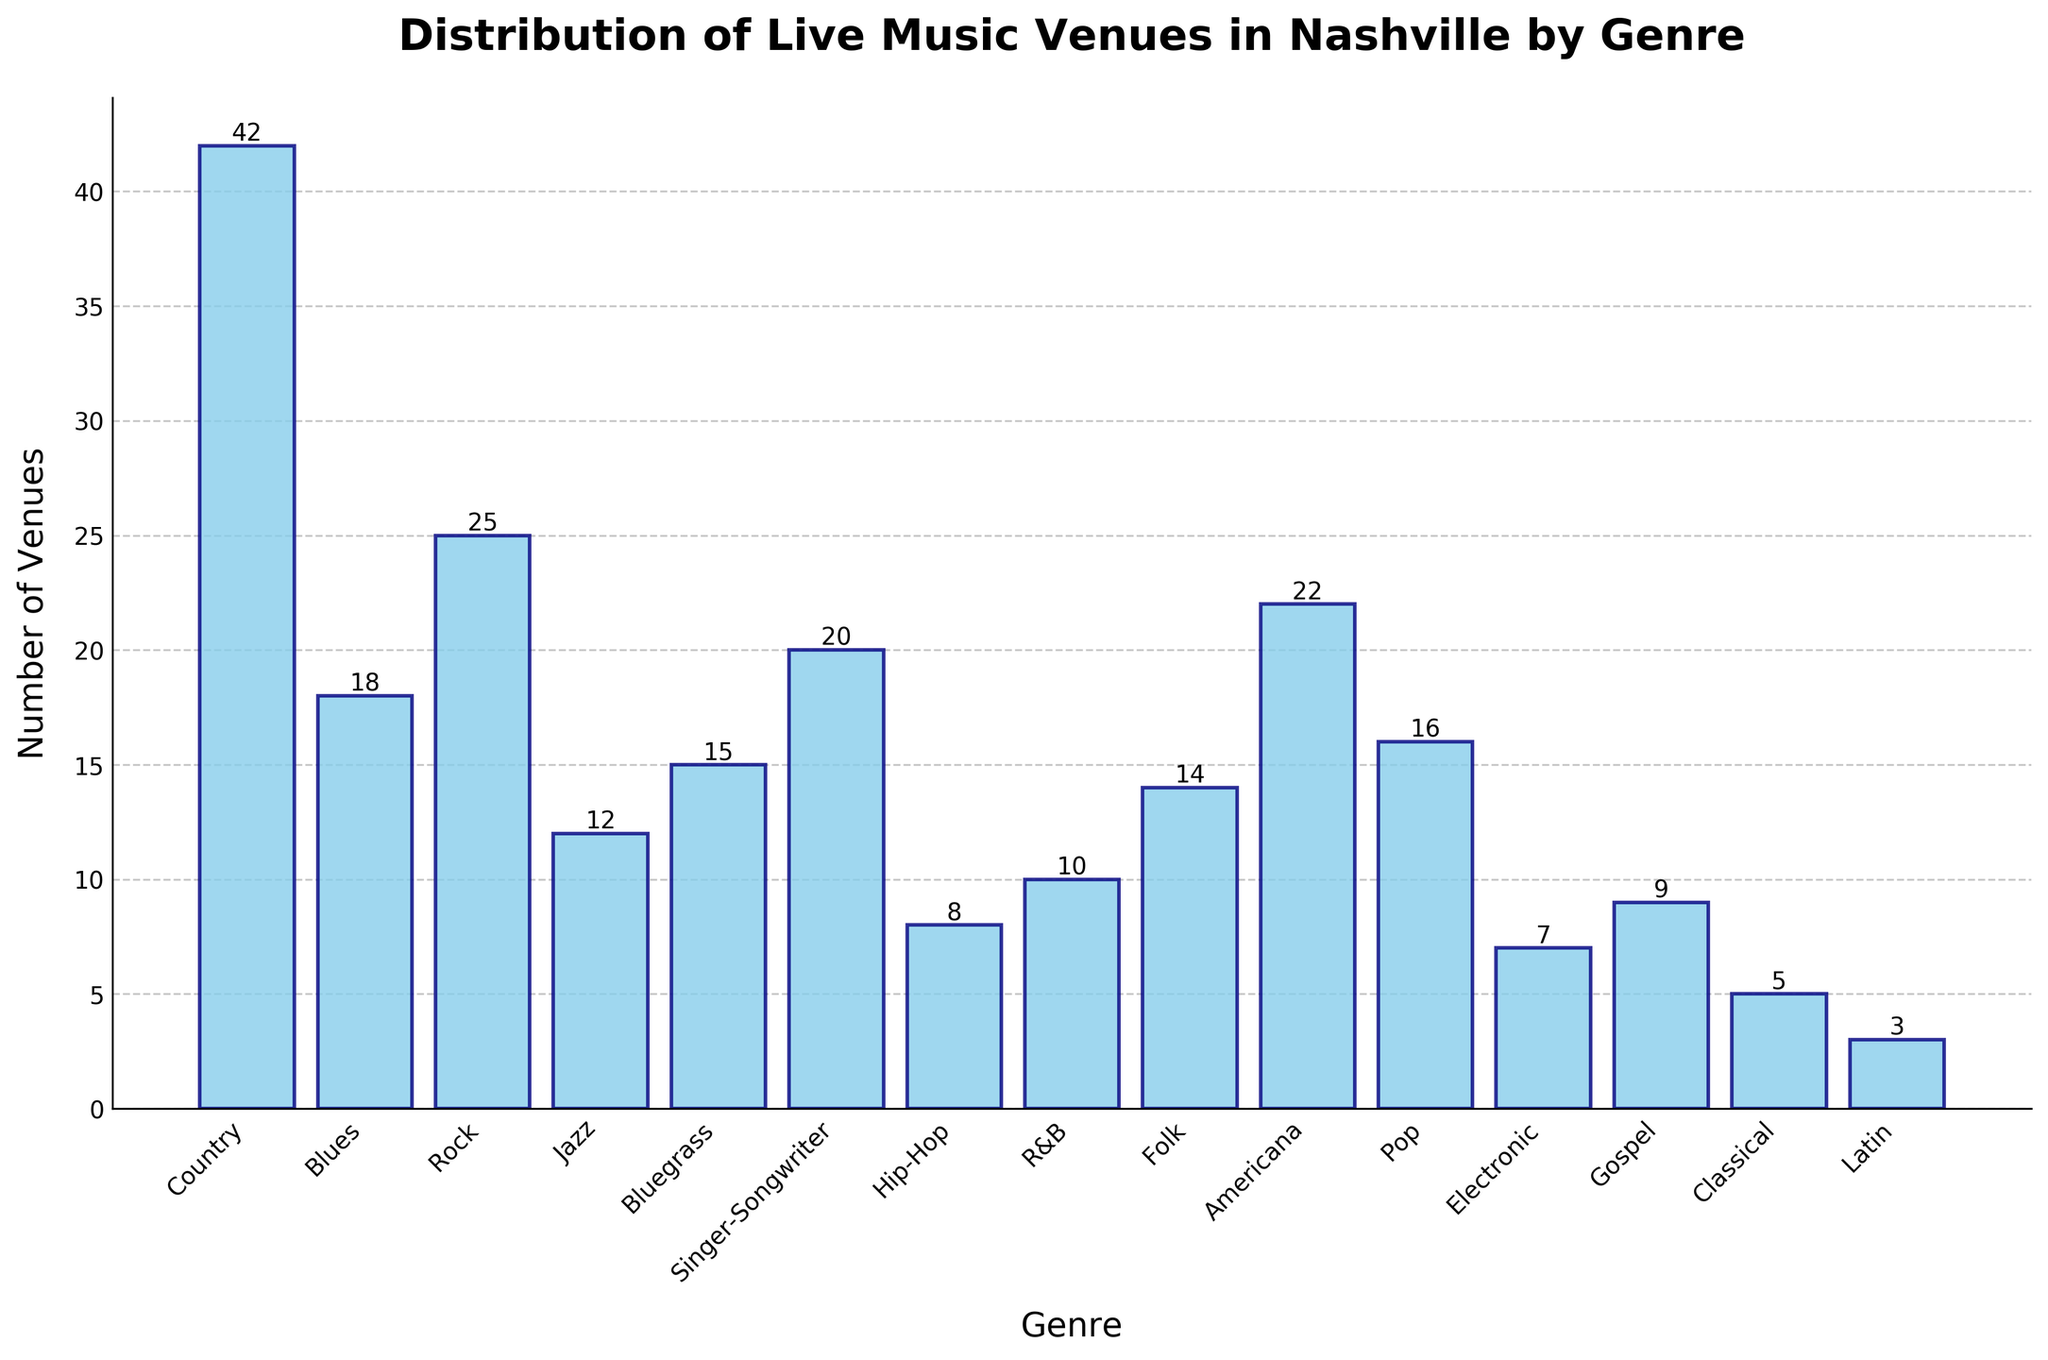What's the most popular genre for live music venues in Nashville? The tallest bar in the bar chart represents the genre with the highest number of venues. The "Country" genre has the tallest bar with 42 venues.
Answer: Country Which genre has more live music venues, Rock or Jazz? Compare the heights of the bars corresponding to "Rock" and "Jazz". The Rock genre has 25 venues and the Jazz genre has 12 venues.
Answer: Rock What's the total number of venues representing the genres of Hip-Hop, R&B, and Gospel combined? Sum the number of venues listed for Hip-Hop (8), R&B (10), and Gospel (9). The total is 8 + 10 + 9 = 27.
Answer: 27 How many genres have more live music venues than the Singer-Songwriter genre? Identify the genres with more than 20 venues (Singer-Songwriter has 20). They are Country (42), Rock (25), and Americana (22). So, there are 3 genres.
Answer: 3 What is the difference in the number of venues between the genres Americana and Bluegrass? Subtract the number of Bluegrass venues (15) from the number of Americana venues (22): 22 - 15 = 7.
Answer: 7 What percentage of the total venues does the Latin genre represent? First, calculate the total number of venues by summing up all of them. The total is 42 + 18 + 25 + 12 + 15 + 20 + 8 + 10 + 14 + 22 + 16 + 7 + 9 + 5 + 3 = 226. Then, divide the number of Latin venues (3) by the total and multiply by 100: (3 / 226) * 100 ≈ 1.33%.
Answer: 1.33% Is there a genre with exactly the same number of venues as the Pop genre? Identify the number of venues for Pop (16), and compare it with venues of other genres. Folk also has 16 venues.
Answer: Folk Which genre has the least number of live music venues in Nashville? The shortest bar in the bar chart represents the genre with the least number of venues. The "Latin" genre has the shortest bar with 3 venues.
Answer: Latin 